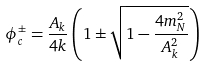<formula> <loc_0><loc_0><loc_500><loc_500>\phi _ { c } ^ { \pm } = \frac { A _ { k } } { 4 k } \left ( 1 \pm \sqrt { 1 - \frac { 4 m _ { N } ^ { 2 } } { A _ { k } ^ { 2 } } } \right )</formula> 